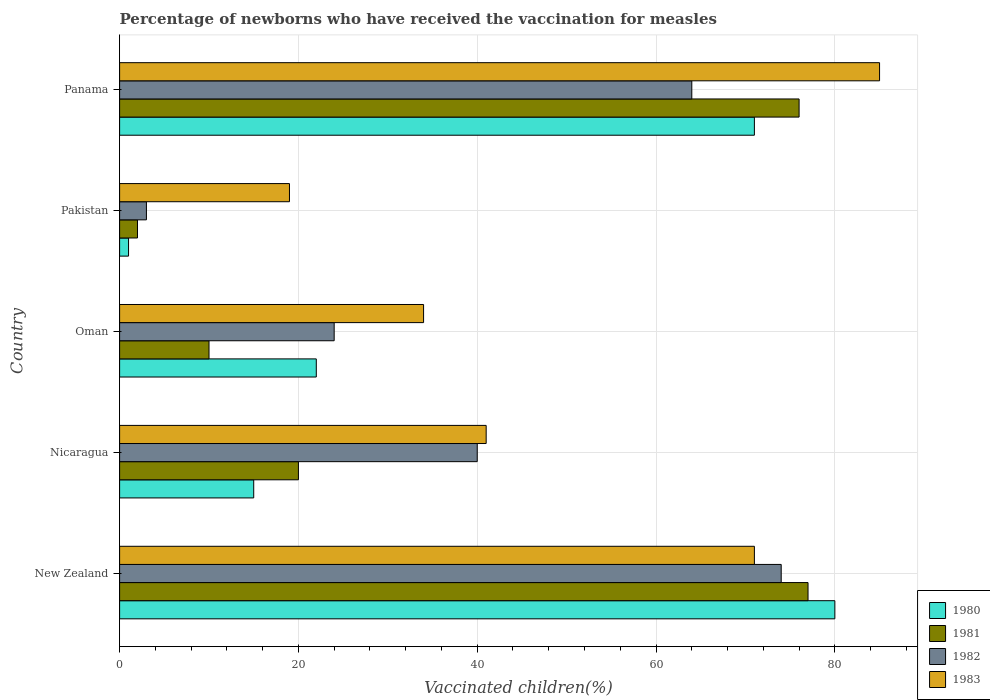How many different coloured bars are there?
Offer a terse response. 4. How many groups of bars are there?
Your response must be concise. 5. Are the number of bars on each tick of the Y-axis equal?
Offer a terse response. Yes. How many bars are there on the 5th tick from the top?
Give a very brief answer. 4. How many bars are there on the 3rd tick from the bottom?
Ensure brevity in your answer.  4. What is the label of the 4th group of bars from the top?
Make the answer very short. Nicaragua. In which country was the percentage of vaccinated children in 1983 maximum?
Offer a terse response. Panama. What is the total percentage of vaccinated children in 1982 in the graph?
Offer a terse response. 205. What is the difference between the percentage of vaccinated children in 1981 in New Zealand and that in Pakistan?
Ensure brevity in your answer.  75. What is the difference between the percentage of vaccinated children in 1980 in Nicaragua and the percentage of vaccinated children in 1981 in New Zealand?
Your answer should be compact. -62. What is the average percentage of vaccinated children in 1980 per country?
Give a very brief answer. 37.8. What is the difference between the percentage of vaccinated children in 1980 and percentage of vaccinated children in 1981 in New Zealand?
Provide a short and direct response. 3. What is the ratio of the percentage of vaccinated children in 1982 in Nicaragua to that in Pakistan?
Offer a terse response. 13.33. Is the percentage of vaccinated children in 1983 in New Zealand less than that in Nicaragua?
Provide a short and direct response. No. What is the difference between the highest and the lowest percentage of vaccinated children in 1982?
Provide a short and direct response. 71. Is the sum of the percentage of vaccinated children in 1981 in New Zealand and Pakistan greater than the maximum percentage of vaccinated children in 1980 across all countries?
Provide a succinct answer. No. Is it the case that in every country, the sum of the percentage of vaccinated children in 1981 and percentage of vaccinated children in 1980 is greater than the sum of percentage of vaccinated children in 1982 and percentage of vaccinated children in 1983?
Your answer should be compact. No. How many bars are there?
Your answer should be very brief. 20. How many countries are there in the graph?
Your response must be concise. 5. What is the difference between two consecutive major ticks on the X-axis?
Your response must be concise. 20. How many legend labels are there?
Make the answer very short. 4. How are the legend labels stacked?
Offer a terse response. Vertical. What is the title of the graph?
Your answer should be very brief. Percentage of newborns who have received the vaccination for measles. Does "1987" appear as one of the legend labels in the graph?
Keep it short and to the point. No. What is the label or title of the X-axis?
Give a very brief answer. Vaccinated children(%). What is the label or title of the Y-axis?
Provide a short and direct response. Country. What is the Vaccinated children(%) of 1982 in New Zealand?
Provide a succinct answer. 74. What is the Vaccinated children(%) of 1981 in Nicaragua?
Provide a succinct answer. 20. What is the Vaccinated children(%) of 1980 in Oman?
Your response must be concise. 22. What is the Vaccinated children(%) in 1981 in Oman?
Ensure brevity in your answer.  10. What is the Vaccinated children(%) in 1982 in Oman?
Provide a short and direct response. 24. What is the Vaccinated children(%) in 1980 in Pakistan?
Make the answer very short. 1. What is the Vaccinated children(%) of 1981 in Pakistan?
Offer a terse response. 2. What is the Vaccinated children(%) in 1981 in Panama?
Offer a terse response. 76. What is the Vaccinated children(%) in 1982 in Panama?
Your response must be concise. 64. What is the Vaccinated children(%) in 1983 in Panama?
Offer a very short reply. 85. Across all countries, what is the maximum Vaccinated children(%) of 1983?
Provide a succinct answer. 85. Across all countries, what is the minimum Vaccinated children(%) in 1980?
Ensure brevity in your answer.  1. Across all countries, what is the minimum Vaccinated children(%) of 1981?
Ensure brevity in your answer.  2. Across all countries, what is the minimum Vaccinated children(%) of 1983?
Give a very brief answer. 19. What is the total Vaccinated children(%) in 1980 in the graph?
Ensure brevity in your answer.  189. What is the total Vaccinated children(%) of 1981 in the graph?
Make the answer very short. 185. What is the total Vaccinated children(%) in 1982 in the graph?
Your answer should be very brief. 205. What is the total Vaccinated children(%) of 1983 in the graph?
Your answer should be very brief. 250. What is the difference between the Vaccinated children(%) in 1981 in New Zealand and that in Nicaragua?
Provide a succinct answer. 57. What is the difference between the Vaccinated children(%) of 1982 in New Zealand and that in Nicaragua?
Ensure brevity in your answer.  34. What is the difference between the Vaccinated children(%) in 1983 in New Zealand and that in Nicaragua?
Offer a very short reply. 30. What is the difference between the Vaccinated children(%) of 1982 in New Zealand and that in Oman?
Your response must be concise. 50. What is the difference between the Vaccinated children(%) of 1980 in New Zealand and that in Pakistan?
Provide a succinct answer. 79. What is the difference between the Vaccinated children(%) of 1981 in New Zealand and that in Pakistan?
Ensure brevity in your answer.  75. What is the difference between the Vaccinated children(%) in 1983 in New Zealand and that in Pakistan?
Ensure brevity in your answer.  52. What is the difference between the Vaccinated children(%) of 1981 in New Zealand and that in Panama?
Provide a short and direct response. 1. What is the difference between the Vaccinated children(%) in 1982 in New Zealand and that in Panama?
Provide a succinct answer. 10. What is the difference between the Vaccinated children(%) in 1980 in Nicaragua and that in Oman?
Your answer should be very brief. -7. What is the difference between the Vaccinated children(%) of 1981 in Nicaragua and that in Oman?
Give a very brief answer. 10. What is the difference between the Vaccinated children(%) of 1982 in Nicaragua and that in Oman?
Give a very brief answer. 16. What is the difference between the Vaccinated children(%) in 1980 in Nicaragua and that in Pakistan?
Offer a terse response. 14. What is the difference between the Vaccinated children(%) of 1981 in Nicaragua and that in Pakistan?
Give a very brief answer. 18. What is the difference between the Vaccinated children(%) of 1982 in Nicaragua and that in Pakistan?
Provide a succinct answer. 37. What is the difference between the Vaccinated children(%) of 1983 in Nicaragua and that in Pakistan?
Keep it short and to the point. 22. What is the difference between the Vaccinated children(%) of 1980 in Nicaragua and that in Panama?
Keep it short and to the point. -56. What is the difference between the Vaccinated children(%) in 1981 in Nicaragua and that in Panama?
Provide a succinct answer. -56. What is the difference between the Vaccinated children(%) of 1983 in Nicaragua and that in Panama?
Make the answer very short. -44. What is the difference between the Vaccinated children(%) in 1980 in Oman and that in Pakistan?
Keep it short and to the point. 21. What is the difference between the Vaccinated children(%) in 1981 in Oman and that in Pakistan?
Offer a terse response. 8. What is the difference between the Vaccinated children(%) in 1983 in Oman and that in Pakistan?
Provide a succinct answer. 15. What is the difference between the Vaccinated children(%) of 1980 in Oman and that in Panama?
Your response must be concise. -49. What is the difference between the Vaccinated children(%) of 1981 in Oman and that in Panama?
Provide a succinct answer. -66. What is the difference between the Vaccinated children(%) of 1982 in Oman and that in Panama?
Provide a short and direct response. -40. What is the difference between the Vaccinated children(%) of 1983 in Oman and that in Panama?
Make the answer very short. -51. What is the difference between the Vaccinated children(%) in 1980 in Pakistan and that in Panama?
Your answer should be very brief. -70. What is the difference between the Vaccinated children(%) of 1981 in Pakistan and that in Panama?
Offer a very short reply. -74. What is the difference between the Vaccinated children(%) of 1982 in Pakistan and that in Panama?
Keep it short and to the point. -61. What is the difference between the Vaccinated children(%) of 1983 in Pakistan and that in Panama?
Your answer should be very brief. -66. What is the difference between the Vaccinated children(%) of 1981 in New Zealand and the Vaccinated children(%) of 1982 in Nicaragua?
Provide a short and direct response. 37. What is the difference between the Vaccinated children(%) of 1980 in New Zealand and the Vaccinated children(%) of 1981 in Oman?
Provide a succinct answer. 70. What is the difference between the Vaccinated children(%) of 1980 in New Zealand and the Vaccinated children(%) of 1983 in Oman?
Provide a succinct answer. 46. What is the difference between the Vaccinated children(%) of 1981 in New Zealand and the Vaccinated children(%) of 1983 in Oman?
Ensure brevity in your answer.  43. What is the difference between the Vaccinated children(%) of 1980 in New Zealand and the Vaccinated children(%) of 1982 in Pakistan?
Make the answer very short. 77. What is the difference between the Vaccinated children(%) of 1980 in New Zealand and the Vaccinated children(%) of 1981 in Panama?
Provide a succinct answer. 4. What is the difference between the Vaccinated children(%) in 1980 in New Zealand and the Vaccinated children(%) in 1982 in Panama?
Offer a terse response. 16. What is the difference between the Vaccinated children(%) in 1981 in New Zealand and the Vaccinated children(%) in 1983 in Panama?
Make the answer very short. -8. What is the difference between the Vaccinated children(%) of 1980 in Nicaragua and the Vaccinated children(%) of 1981 in Oman?
Your response must be concise. 5. What is the difference between the Vaccinated children(%) of 1980 in Nicaragua and the Vaccinated children(%) of 1982 in Oman?
Your response must be concise. -9. What is the difference between the Vaccinated children(%) of 1980 in Nicaragua and the Vaccinated children(%) of 1983 in Oman?
Your answer should be very brief. -19. What is the difference between the Vaccinated children(%) of 1981 in Nicaragua and the Vaccinated children(%) of 1982 in Oman?
Offer a very short reply. -4. What is the difference between the Vaccinated children(%) of 1981 in Nicaragua and the Vaccinated children(%) of 1983 in Oman?
Keep it short and to the point. -14. What is the difference between the Vaccinated children(%) of 1980 in Nicaragua and the Vaccinated children(%) of 1981 in Pakistan?
Your response must be concise. 13. What is the difference between the Vaccinated children(%) of 1981 in Nicaragua and the Vaccinated children(%) of 1982 in Pakistan?
Ensure brevity in your answer.  17. What is the difference between the Vaccinated children(%) in 1980 in Nicaragua and the Vaccinated children(%) in 1981 in Panama?
Your answer should be compact. -61. What is the difference between the Vaccinated children(%) in 1980 in Nicaragua and the Vaccinated children(%) in 1982 in Panama?
Provide a short and direct response. -49. What is the difference between the Vaccinated children(%) in 1980 in Nicaragua and the Vaccinated children(%) in 1983 in Panama?
Ensure brevity in your answer.  -70. What is the difference between the Vaccinated children(%) of 1981 in Nicaragua and the Vaccinated children(%) of 1982 in Panama?
Provide a succinct answer. -44. What is the difference between the Vaccinated children(%) in 1981 in Nicaragua and the Vaccinated children(%) in 1983 in Panama?
Your response must be concise. -65. What is the difference between the Vaccinated children(%) of 1982 in Nicaragua and the Vaccinated children(%) of 1983 in Panama?
Provide a succinct answer. -45. What is the difference between the Vaccinated children(%) of 1981 in Oman and the Vaccinated children(%) of 1983 in Pakistan?
Offer a terse response. -9. What is the difference between the Vaccinated children(%) of 1982 in Oman and the Vaccinated children(%) of 1983 in Pakistan?
Offer a terse response. 5. What is the difference between the Vaccinated children(%) of 1980 in Oman and the Vaccinated children(%) of 1981 in Panama?
Provide a succinct answer. -54. What is the difference between the Vaccinated children(%) of 1980 in Oman and the Vaccinated children(%) of 1982 in Panama?
Offer a very short reply. -42. What is the difference between the Vaccinated children(%) of 1980 in Oman and the Vaccinated children(%) of 1983 in Panama?
Make the answer very short. -63. What is the difference between the Vaccinated children(%) of 1981 in Oman and the Vaccinated children(%) of 1982 in Panama?
Give a very brief answer. -54. What is the difference between the Vaccinated children(%) of 1981 in Oman and the Vaccinated children(%) of 1983 in Panama?
Offer a terse response. -75. What is the difference between the Vaccinated children(%) in 1982 in Oman and the Vaccinated children(%) in 1983 in Panama?
Ensure brevity in your answer.  -61. What is the difference between the Vaccinated children(%) in 1980 in Pakistan and the Vaccinated children(%) in 1981 in Panama?
Provide a succinct answer. -75. What is the difference between the Vaccinated children(%) in 1980 in Pakistan and the Vaccinated children(%) in 1982 in Panama?
Offer a terse response. -63. What is the difference between the Vaccinated children(%) of 1980 in Pakistan and the Vaccinated children(%) of 1983 in Panama?
Make the answer very short. -84. What is the difference between the Vaccinated children(%) in 1981 in Pakistan and the Vaccinated children(%) in 1982 in Panama?
Your answer should be compact. -62. What is the difference between the Vaccinated children(%) in 1981 in Pakistan and the Vaccinated children(%) in 1983 in Panama?
Ensure brevity in your answer.  -83. What is the difference between the Vaccinated children(%) in 1982 in Pakistan and the Vaccinated children(%) in 1983 in Panama?
Your response must be concise. -82. What is the average Vaccinated children(%) of 1980 per country?
Offer a very short reply. 37.8. What is the average Vaccinated children(%) in 1983 per country?
Offer a terse response. 50. What is the difference between the Vaccinated children(%) of 1981 and Vaccinated children(%) of 1982 in New Zealand?
Your response must be concise. 3. What is the difference between the Vaccinated children(%) of 1981 and Vaccinated children(%) of 1983 in New Zealand?
Offer a terse response. 6. What is the difference between the Vaccinated children(%) of 1982 and Vaccinated children(%) of 1983 in New Zealand?
Ensure brevity in your answer.  3. What is the difference between the Vaccinated children(%) of 1980 and Vaccinated children(%) of 1981 in Nicaragua?
Your answer should be compact. -5. What is the difference between the Vaccinated children(%) in 1980 and Vaccinated children(%) in 1982 in Nicaragua?
Your answer should be very brief. -25. What is the difference between the Vaccinated children(%) in 1982 and Vaccinated children(%) in 1983 in Nicaragua?
Provide a short and direct response. -1. What is the difference between the Vaccinated children(%) in 1980 and Vaccinated children(%) in 1982 in Oman?
Provide a succinct answer. -2. What is the difference between the Vaccinated children(%) of 1980 and Vaccinated children(%) of 1983 in Pakistan?
Your answer should be compact. -18. What is the difference between the Vaccinated children(%) of 1981 and Vaccinated children(%) of 1982 in Pakistan?
Provide a succinct answer. -1. What is the difference between the Vaccinated children(%) in 1981 and Vaccinated children(%) in 1983 in Pakistan?
Make the answer very short. -17. What is the difference between the Vaccinated children(%) in 1980 and Vaccinated children(%) in 1981 in Panama?
Offer a very short reply. -5. What is the difference between the Vaccinated children(%) in 1980 and Vaccinated children(%) in 1983 in Panama?
Your answer should be very brief. -14. What is the difference between the Vaccinated children(%) in 1981 and Vaccinated children(%) in 1982 in Panama?
Give a very brief answer. 12. What is the difference between the Vaccinated children(%) of 1982 and Vaccinated children(%) of 1983 in Panama?
Your response must be concise. -21. What is the ratio of the Vaccinated children(%) of 1980 in New Zealand to that in Nicaragua?
Your answer should be very brief. 5.33. What is the ratio of the Vaccinated children(%) in 1981 in New Zealand to that in Nicaragua?
Provide a succinct answer. 3.85. What is the ratio of the Vaccinated children(%) in 1982 in New Zealand to that in Nicaragua?
Keep it short and to the point. 1.85. What is the ratio of the Vaccinated children(%) of 1983 in New Zealand to that in Nicaragua?
Your answer should be very brief. 1.73. What is the ratio of the Vaccinated children(%) of 1980 in New Zealand to that in Oman?
Make the answer very short. 3.64. What is the ratio of the Vaccinated children(%) of 1982 in New Zealand to that in Oman?
Your answer should be very brief. 3.08. What is the ratio of the Vaccinated children(%) in 1983 in New Zealand to that in Oman?
Give a very brief answer. 2.09. What is the ratio of the Vaccinated children(%) of 1981 in New Zealand to that in Pakistan?
Make the answer very short. 38.5. What is the ratio of the Vaccinated children(%) of 1982 in New Zealand to that in Pakistan?
Your answer should be compact. 24.67. What is the ratio of the Vaccinated children(%) of 1983 in New Zealand to that in Pakistan?
Ensure brevity in your answer.  3.74. What is the ratio of the Vaccinated children(%) of 1980 in New Zealand to that in Panama?
Offer a very short reply. 1.13. What is the ratio of the Vaccinated children(%) of 1981 in New Zealand to that in Panama?
Your answer should be very brief. 1.01. What is the ratio of the Vaccinated children(%) in 1982 in New Zealand to that in Panama?
Offer a terse response. 1.16. What is the ratio of the Vaccinated children(%) of 1983 in New Zealand to that in Panama?
Your answer should be compact. 0.84. What is the ratio of the Vaccinated children(%) of 1980 in Nicaragua to that in Oman?
Offer a very short reply. 0.68. What is the ratio of the Vaccinated children(%) of 1982 in Nicaragua to that in Oman?
Make the answer very short. 1.67. What is the ratio of the Vaccinated children(%) of 1983 in Nicaragua to that in Oman?
Your answer should be very brief. 1.21. What is the ratio of the Vaccinated children(%) of 1981 in Nicaragua to that in Pakistan?
Your response must be concise. 10. What is the ratio of the Vaccinated children(%) of 1982 in Nicaragua to that in Pakistan?
Make the answer very short. 13.33. What is the ratio of the Vaccinated children(%) of 1983 in Nicaragua to that in Pakistan?
Your answer should be compact. 2.16. What is the ratio of the Vaccinated children(%) in 1980 in Nicaragua to that in Panama?
Provide a short and direct response. 0.21. What is the ratio of the Vaccinated children(%) of 1981 in Nicaragua to that in Panama?
Provide a succinct answer. 0.26. What is the ratio of the Vaccinated children(%) of 1983 in Nicaragua to that in Panama?
Ensure brevity in your answer.  0.48. What is the ratio of the Vaccinated children(%) in 1981 in Oman to that in Pakistan?
Your response must be concise. 5. What is the ratio of the Vaccinated children(%) of 1983 in Oman to that in Pakistan?
Keep it short and to the point. 1.79. What is the ratio of the Vaccinated children(%) of 1980 in Oman to that in Panama?
Give a very brief answer. 0.31. What is the ratio of the Vaccinated children(%) in 1981 in Oman to that in Panama?
Give a very brief answer. 0.13. What is the ratio of the Vaccinated children(%) in 1982 in Oman to that in Panama?
Give a very brief answer. 0.38. What is the ratio of the Vaccinated children(%) in 1980 in Pakistan to that in Panama?
Make the answer very short. 0.01. What is the ratio of the Vaccinated children(%) in 1981 in Pakistan to that in Panama?
Ensure brevity in your answer.  0.03. What is the ratio of the Vaccinated children(%) in 1982 in Pakistan to that in Panama?
Provide a short and direct response. 0.05. What is the ratio of the Vaccinated children(%) in 1983 in Pakistan to that in Panama?
Provide a succinct answer. 0.22. What is the difference between the highest and the second highest Vaccinated children(%) of 1981?
Make the answer very short. 1. What is the difference between the highest and the second highest Vaccinated children(%) in 1982?
Keep it short and to the point. 10. What is the difference between the highest and the second highest Vaccinated children(%) in 1983?
Ensure brevity in your answer.  14. What is the difference between the highest and the lowest Vaccinated children(%) of 1980?
Your answer should be compact. 79. What is the difference between the highest and the lowest Vaccinated children(%) in 1982?
Offer a terse response. 71. 